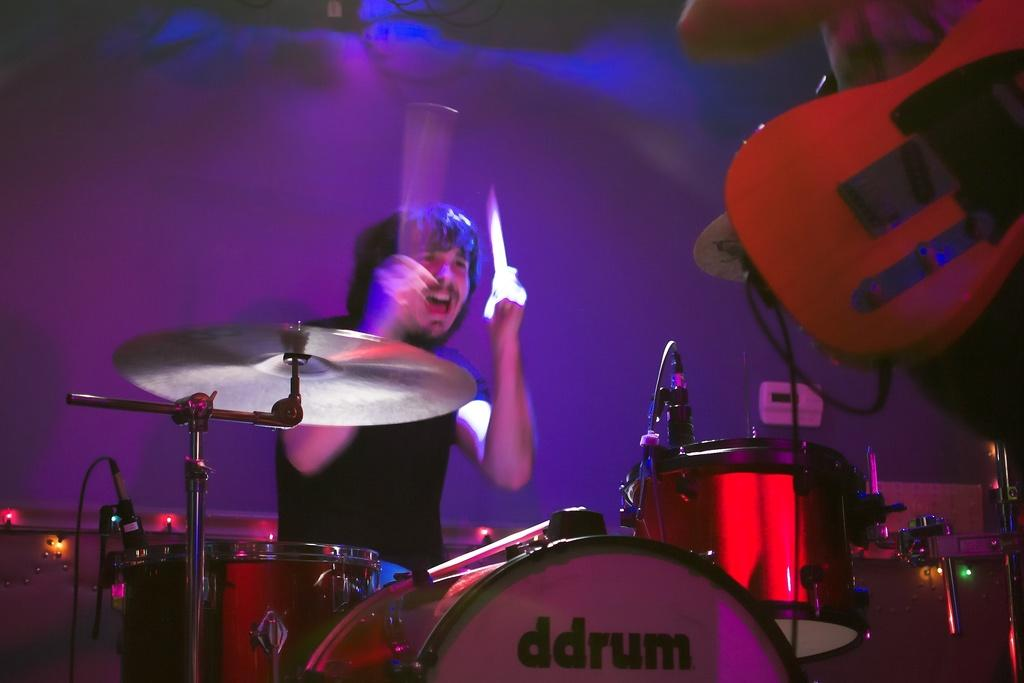Who is the main subject in the image? There is a man in the image. What is the man doing in the image? The man is playing a musical drum. Where is the musical drum located in relation to the man? The musical drum is in front of the man. What type of boats can be seen sailing in the background of the image? There are no boats visible in the image; it features a man playing a musical drum. What riddle is the man trying to solve while playing the drum? There is no indication in the image that the man is trying to solve a riddle while playing the drum. 